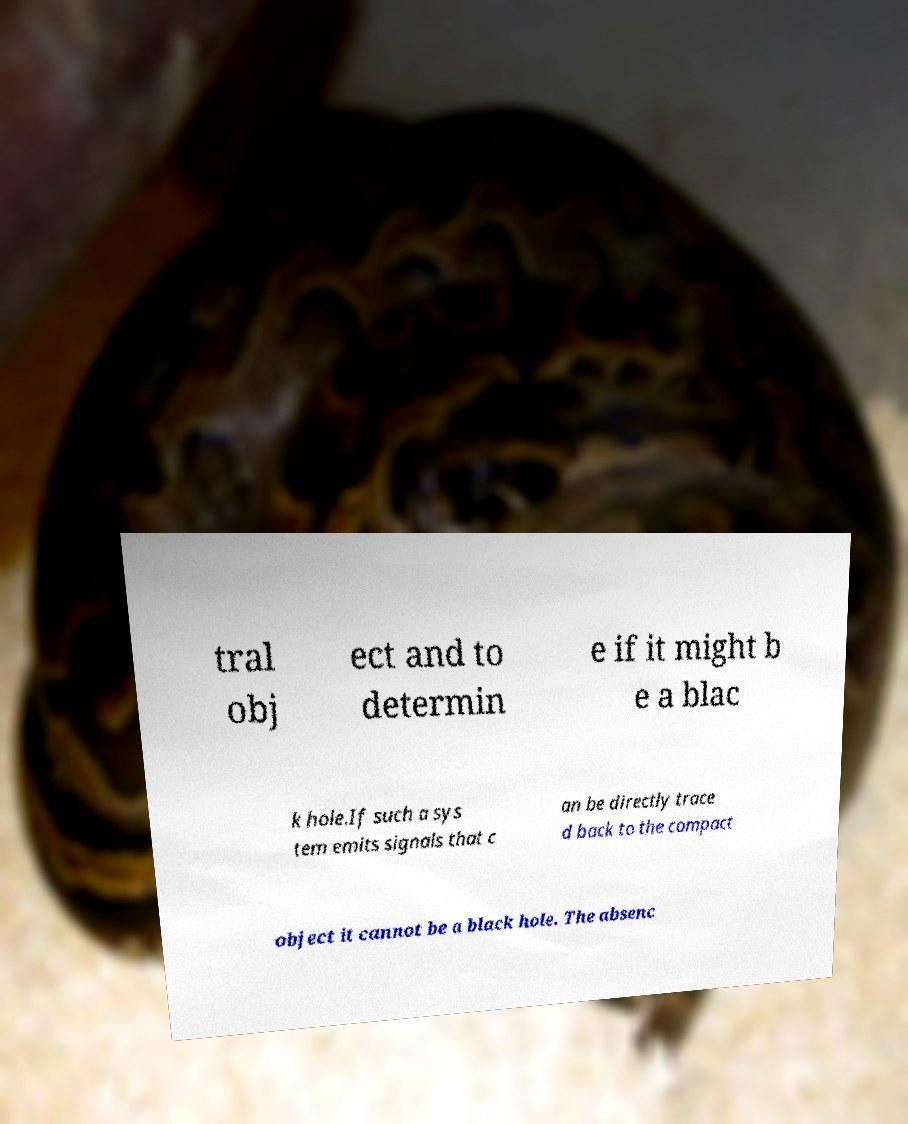Please read and relay the text visible in this image. What does it say? tral obj ect and to determin e if it might b e a blac k hole.If such a sys tem emits signals that c an be directly trace d back to the compact object it cannot be a black hole. The absenc 